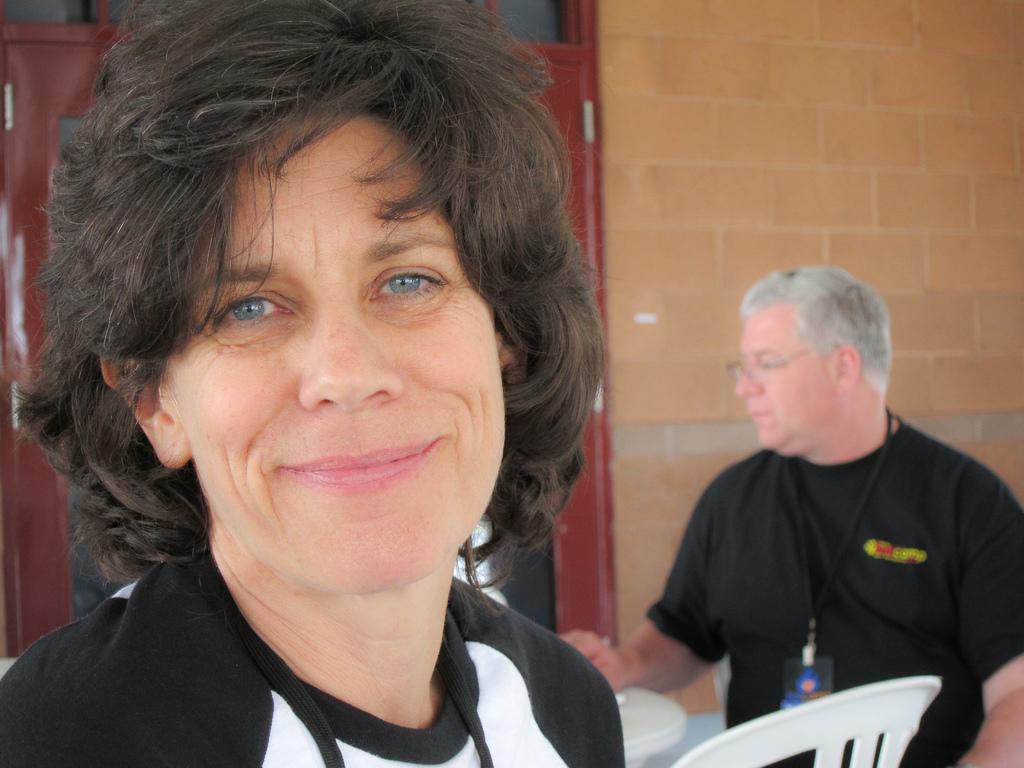In one or two sentences, can you explain what this image depicts? In this picture I can see a woman in front and I see that she is smiling. In the background I can see a man wearing black color t-shirt and I see a chair in front of him and I can see the wall and a red color thing on the left side of this image. 